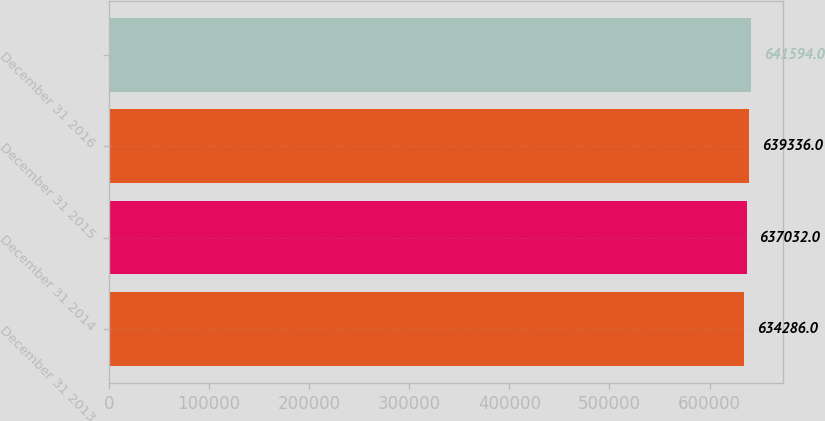Convert chart. <chart><loc_0><loc_0><loc_500><loc_500><bar_chart><fcel>December 31 2013<fcel>December 31 2014<fcel>December 31 2015<fcel>December 31 2016<nl><fcel>634286<fcel>637032<fcel>639336<fcel>641594<nl></chart> 